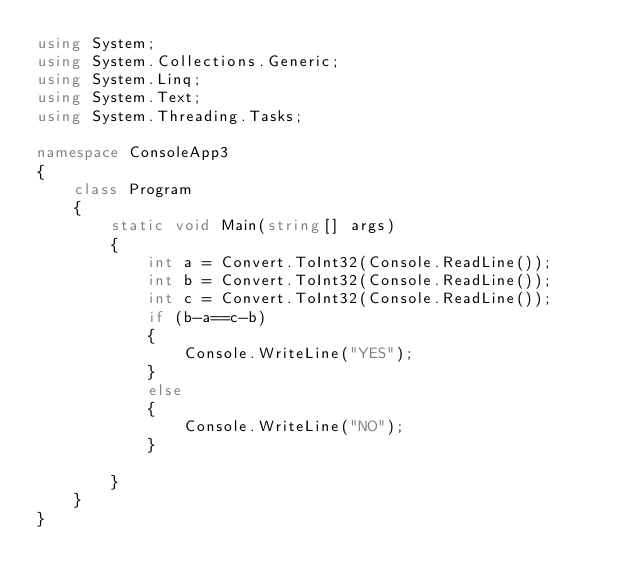Convert code to text. <code><loc_0><loc_0><loc_500><loc_500><_C#_>using System;
using System.Collections.Generic;
using System.Linq;
using System.Text;
using System.Threading.Tasks;

namespace ConsoleApp3
{
    class Program
    {
        static void Main(string[] args)
        {
            int a = Convert.ToInt32(Console.ReadLine());
            int b = Convert.ToInt32(Console.ReadLine());
            int c = Convert.ToInt32(Console.ReadLine());
            if (b-a==c-b)
            {
                Console.WriteLine("YES");
            }
            else
            {
                Console.WriteLine("NO");
            }

        }
    }
}</code> 